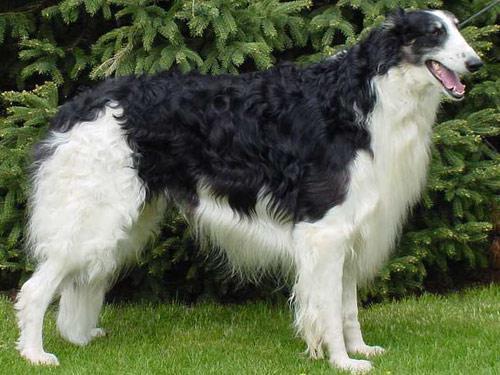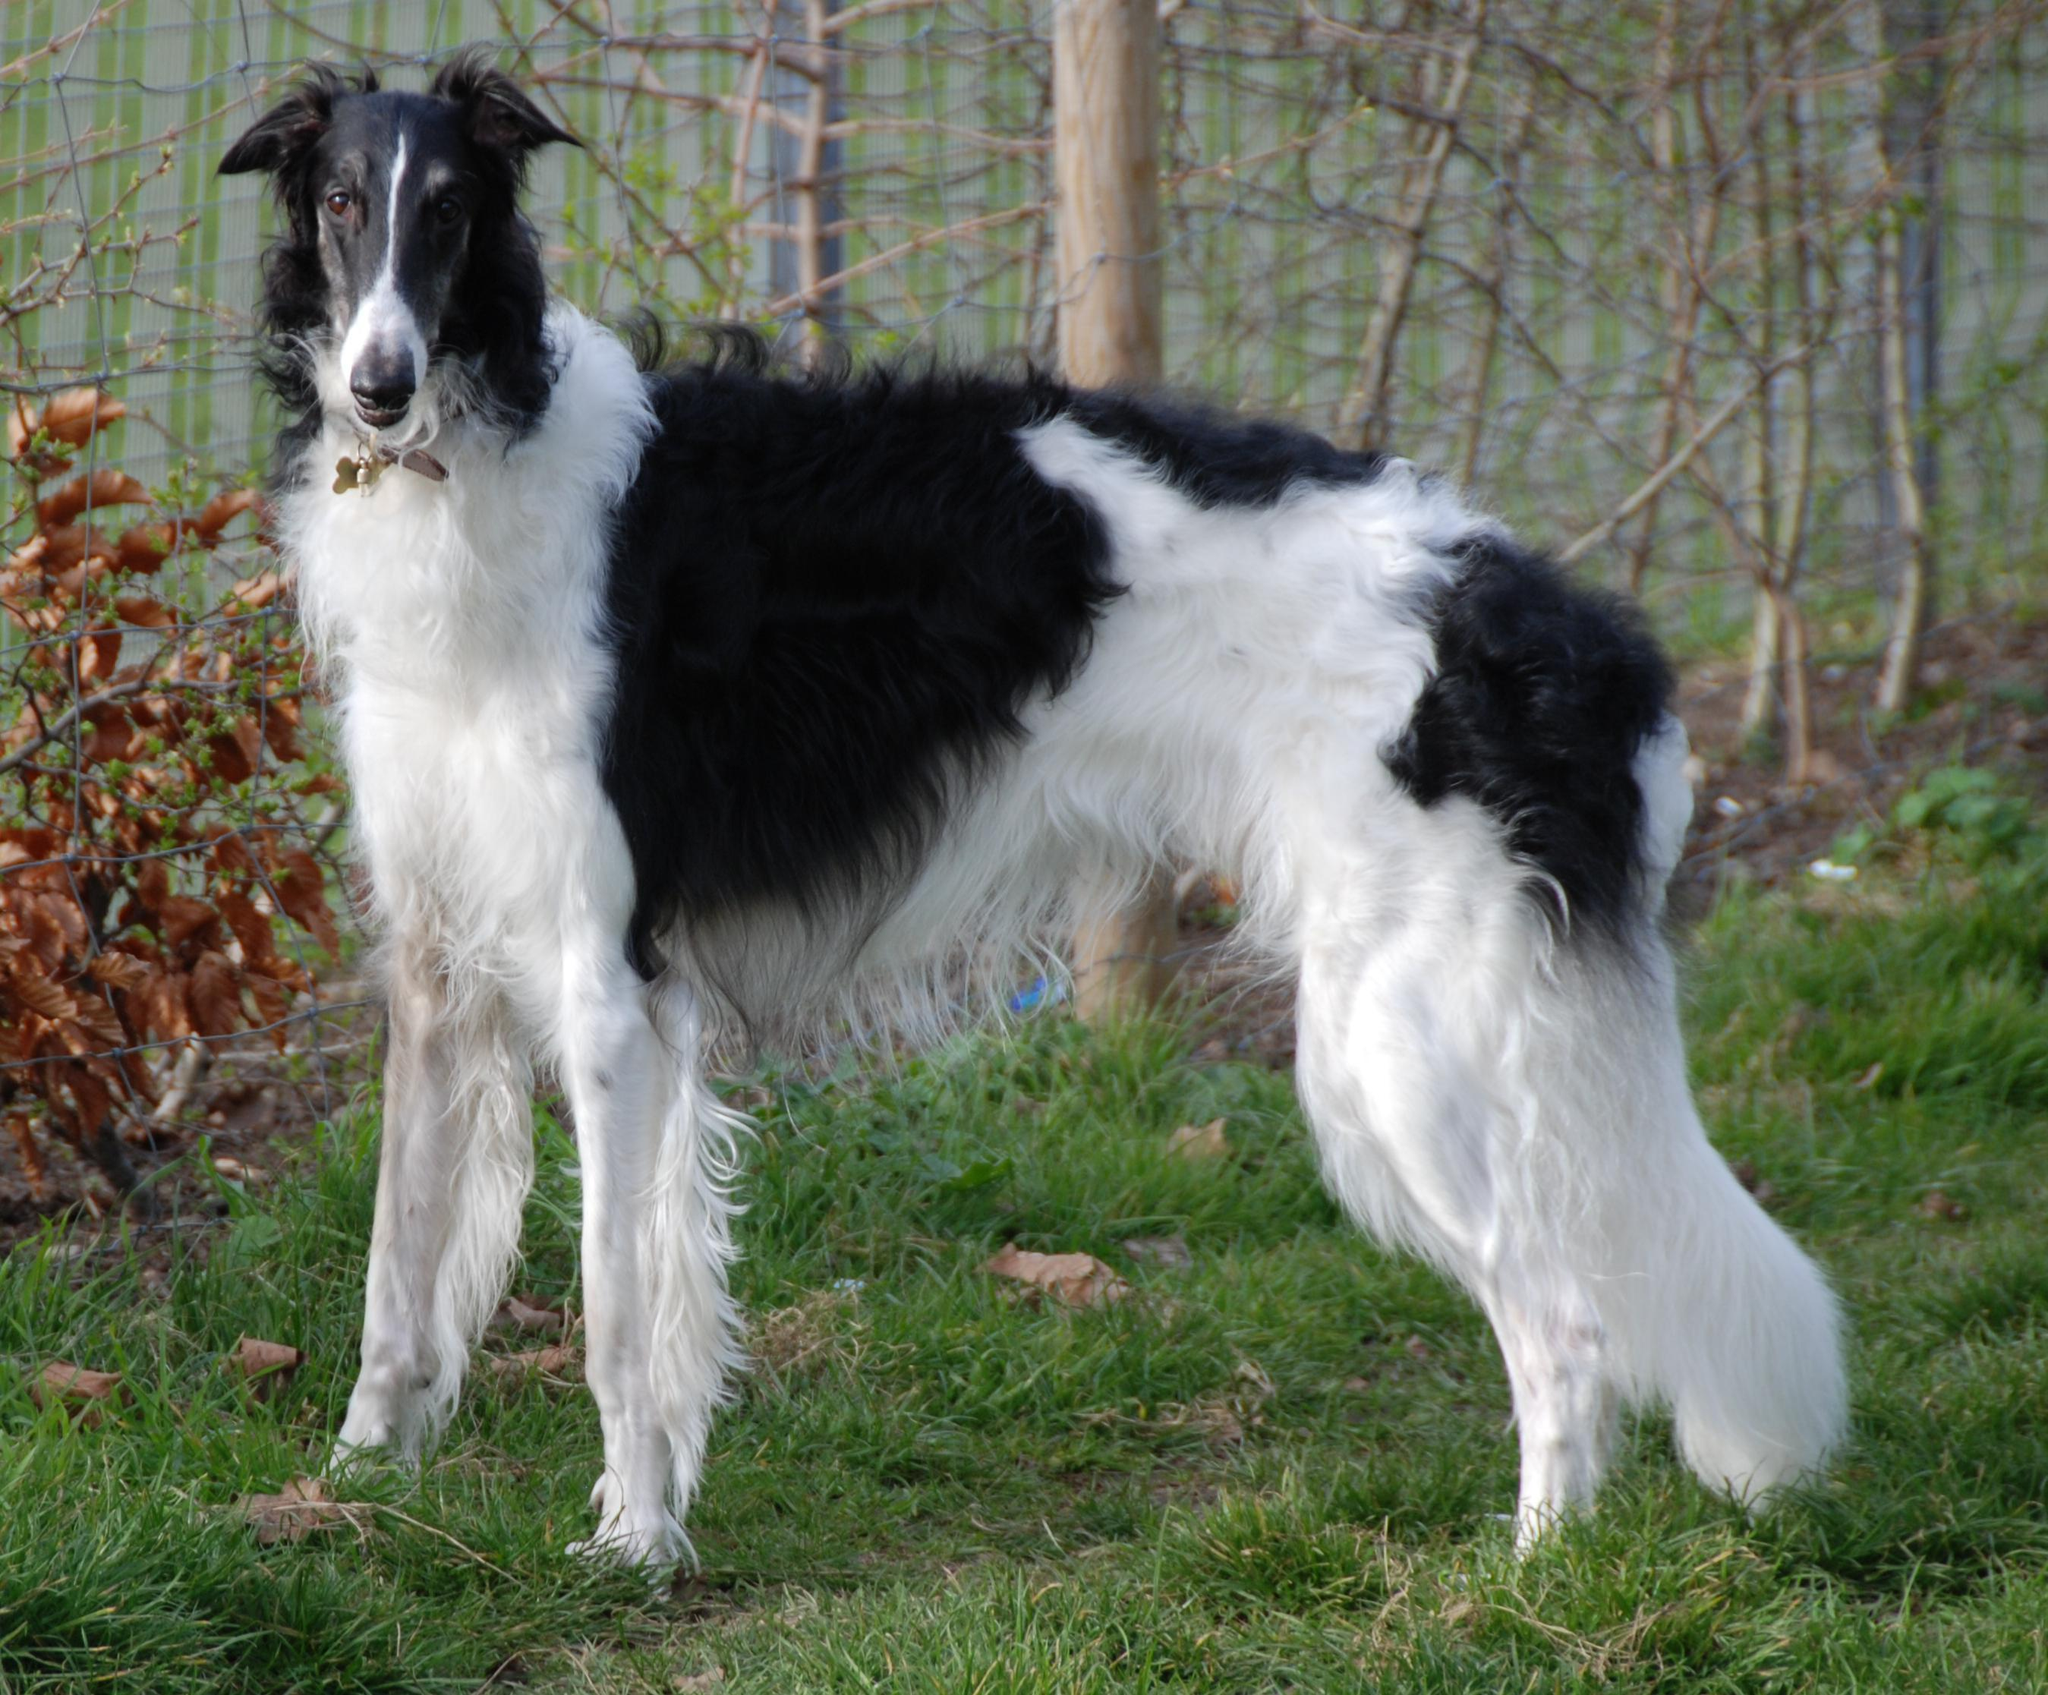The first image is the image on the left, the second image is the image on the right. For the images shown, is this caption "There are at least two dogs in the image on the left." true? Answer yes or no. No. The first image is the image on the left, the second image is the image on the right. For the images displayed, is the sentence "There is exactly one dog in each image." factually correct? Answer yes or no. Yes. 